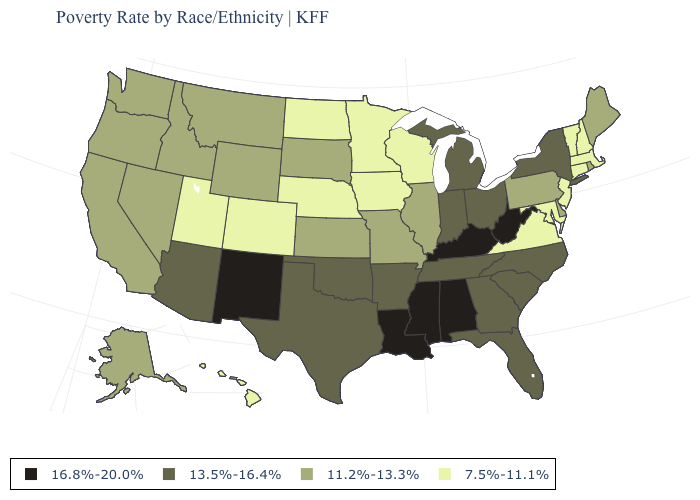Does Colorado have a higher value than Idaho?
Be succinct. No. Name the states that have a value in the range 11.2%-13.3%?
Quick response, please. Alaska, California, Delaware, Idaho, Illinois, Kansas, Maine, Missouri, Montana, Nevada, Oregon, Pennsylvania, Rhode Island, South Dakota, Washington, Wyoming. Which states have the lowest value in the USA?
Answer briefly. Colorado, Connecticut, Hawaii, Iowa, Maryland, Massachusetts, Minnesota, Nebraska, New Hampshire, New Jersey, North Dakota, Utah, Vermont, Virginia, Wisconsin. Among the states that border West Virginia , does Kentucky have the highest value?
Short answer required. Yes. What is the highest value in the West ?
Give a very brief answer. 16.8%-20.0%. How many symbols are there in the legend?
Keep it brief. 4. What is the value of Louisiana?
Keep it brief. 16.8%-20.0%. What is the lowest value in states that border Oregon?
Keep it brief. 11.2%-13.3%. What is the value of Kansas?
Keep it brief. 11.2%-13.3%. What is the lowest value in states that border Nevada?
Answer briefly. 7.5%-11.1%. What is the highest value in the West ?
Short answer required. 16.8%-20.0%. What is the highest value in states that border North Carolina?
Keep it brief. 13.5%-16.4%. Does Florida have the same value as Iowa?
Answer briefly. No. Does South Dakota have the lowest value in the MidWest?
Short answer required. No. Does Alaska have the lowest value in the West?
Answer briefly. No. 